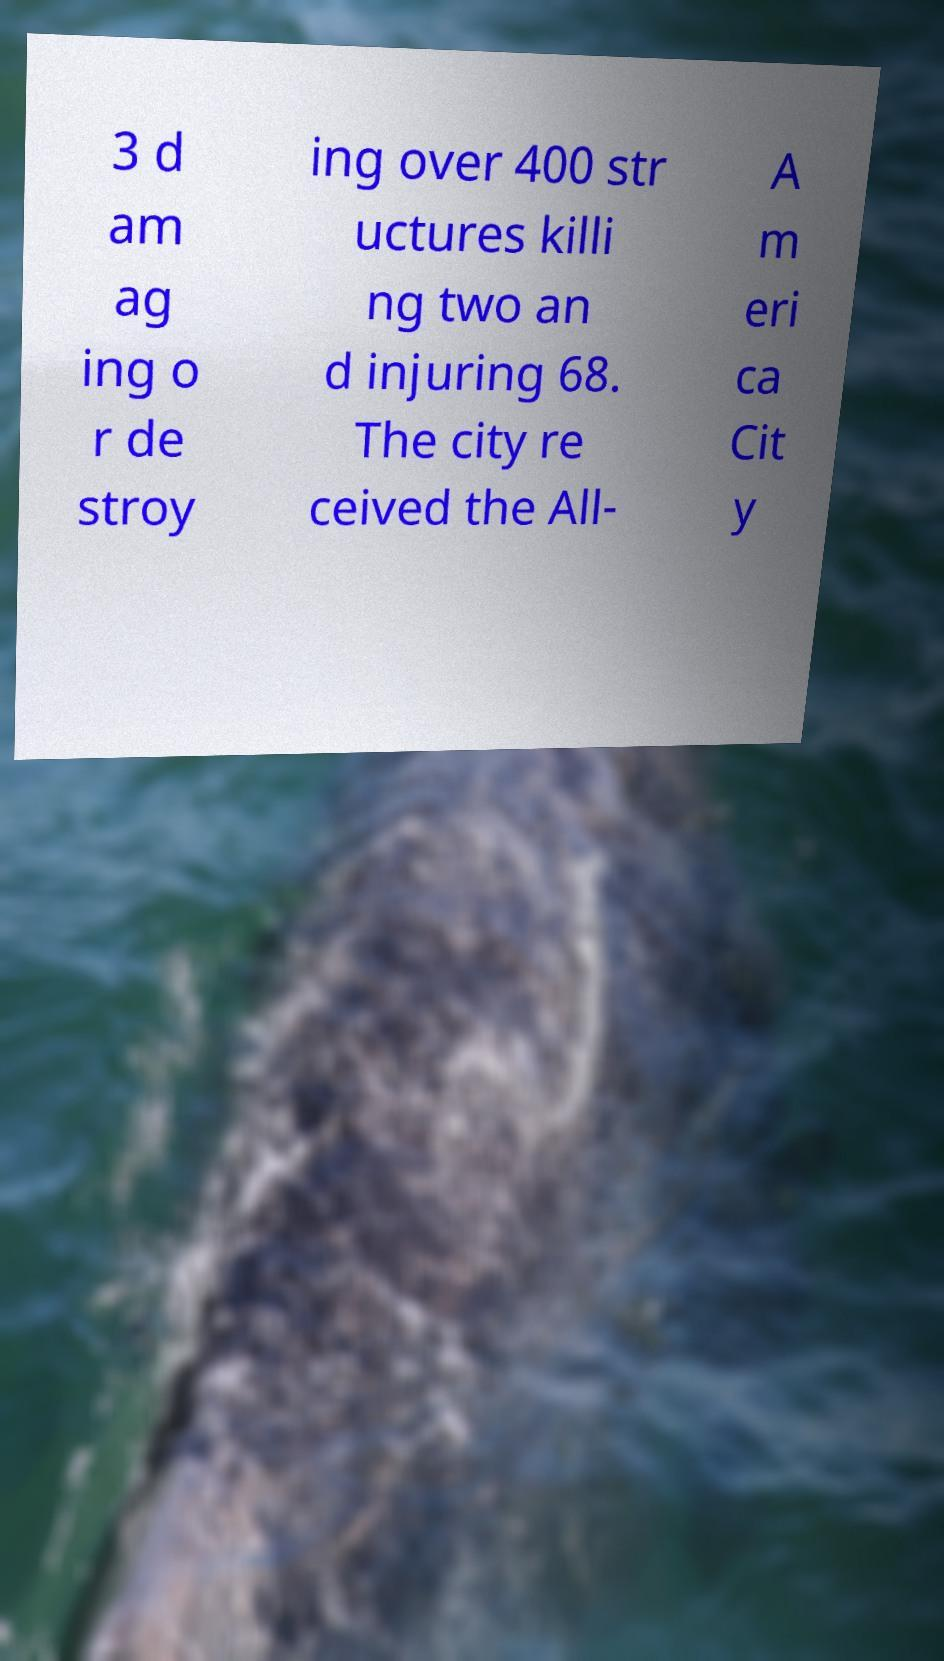Please read and relay the text visible in this image. What does it say? 3 d am ag ing o r de stroy ing over 400 str uctures killi ng two an d injuring 68. The city re ceived the All- A m eri ca Cit y 